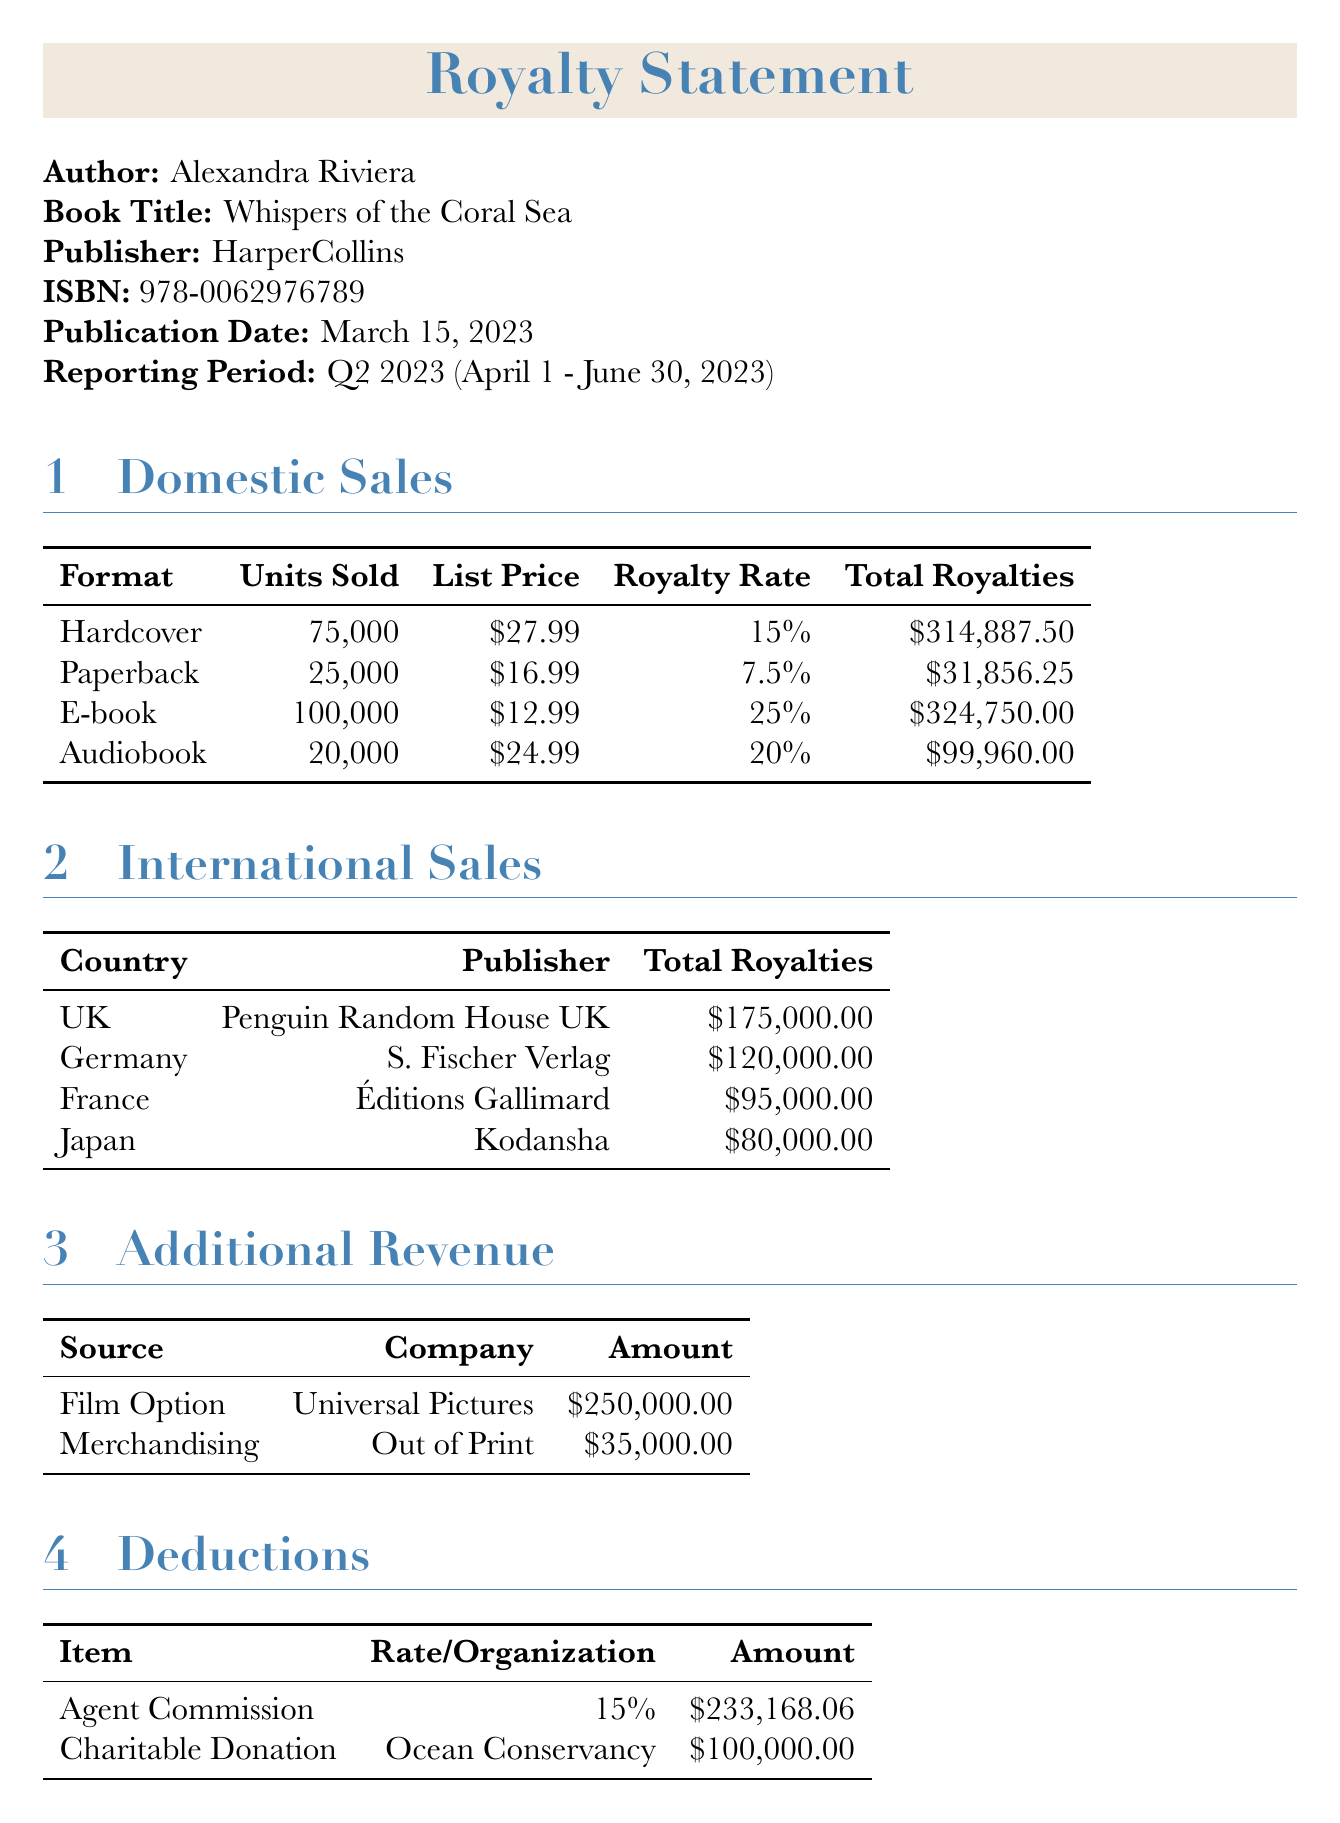what is the author's name? The author's name is provided in the document as part of the invoice details.
Answer: Alexandra Riviera what is the book title? The book title is specified in the invoice details section of the document.
Answer: Whispers of the Coral Sea how many units of hardcover were sold? The number of hardcover units sold is listed in the domestic sales section under hardcover.
Answer: 75000 what is the royalty rate for e-book sales? The royalty rate for e-books is mentioned in the domestic sales section alongside the total royalties.
Answer: 25% what is the total royalty from international sales? Total royalties from international sales are summed up from different countries in the international sales section.
Answer: 470000.00 which publisher is associated with the book sales in Germany? The publisher for sales in Germany is listed in the international sales section of the invoice.
Answer: S. Fischer Verlag what is the amount received from film options? The amount for the film option is specified in the additional revenue section of the document.
Answer: 250000.00 how much was deducted for the agent commission? The agent commission deduction is detailed in the deductions section of this invoice.
Answer: 233168.06 what is the net total of royalties? The net total of royalties is calculated in the total royalties section at the end of the document.
Answer: 1193285.69 